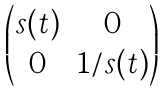<formula> <loc_0><loc_0><loc_500><loc_500>\begin{pmatrix} s ( t ) & 0 \\ 0 & 1 / s ( t ) \end{pmatrix}</formula> 